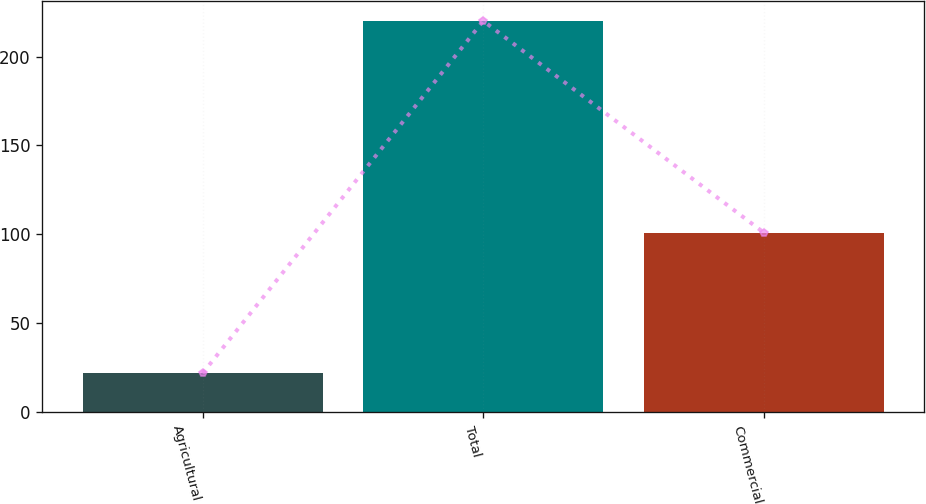<chart> <loc_0><loc_0><loc_500><loc_500><bar_chart><fcel>Agricultural<fcel>Total<fcel>Commercial<nl><fcel>22<fcel>220<fcel>101<nl></chart> 